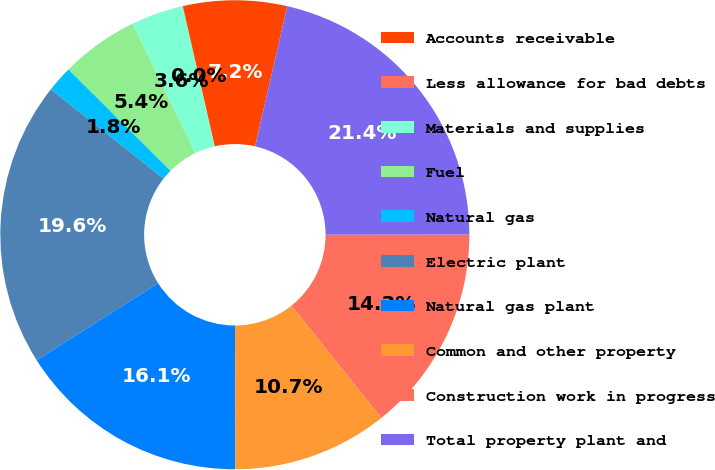<chart> <loc_0><loc_0><loc_500><loc_500><pie_chart><fcel>Accounts receivable<fcel>Less allowance for bad debts<fcel>Materials and supplies<fcel>Fuel<fcel>Natural gas<fcel>Electric plant<fcel>Natural gas plant<fcel>Common and other property<fcel>Construction work in progress<fcel>Total property plant and<nl><fcel>7.15%<fcel>0.03%<fcel>3.59%<fcel>5.37%<fcel>1.81%<fcel>19.61%<fcel>16.05%<fcel>10.71%<fcel>14.27%<fcel>21.39%<nl></chart> 